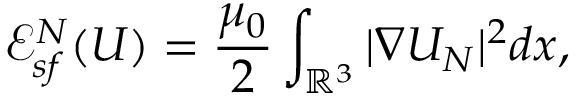Convert formula to latex. <formula><loc_0><loc_0><loc_500><loc_500>{ \ m a t h s c r E } _ { s f } ^ { N } ( U ) = \frac { \mu _ { 0 } } { 2 } \int _ { { \mathbb { R } } ^ { 3 } } | \nabla U _ { N } | ^ { 2 } d x ,</formula> 